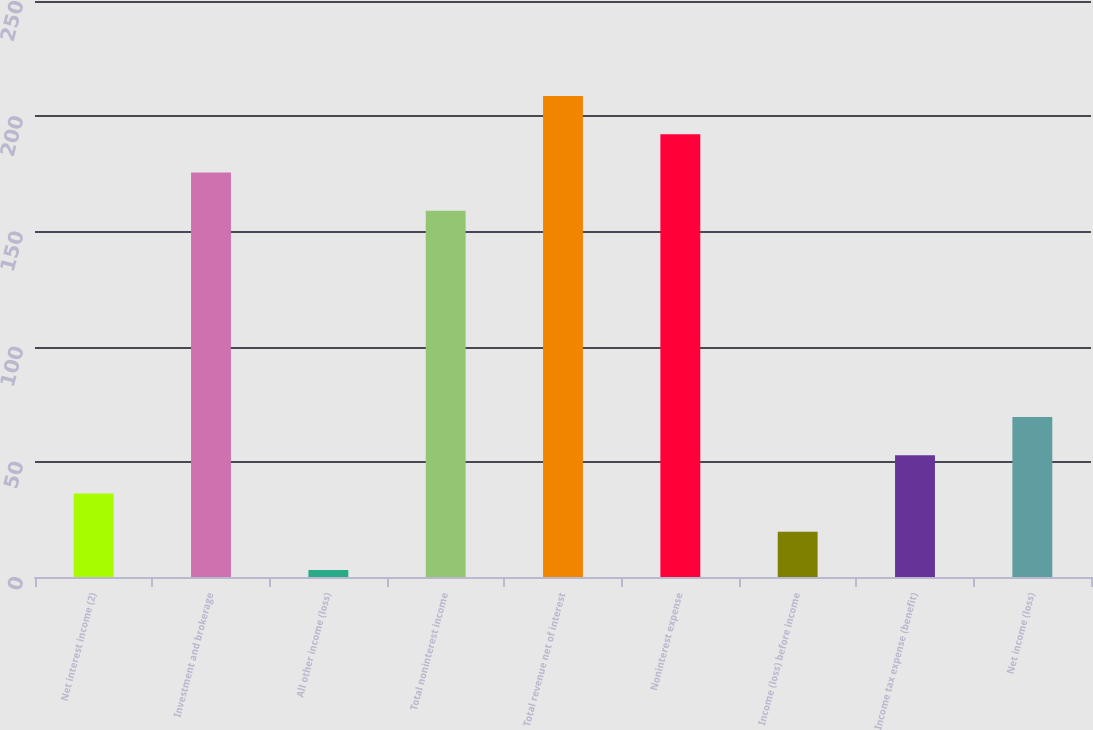<chart> <loc_0><loc_0><loc_500><loc_500><bar_chart><fcel>Net interest income (2)<fcel>Investment and brokerage<fcel>All other income (loss)<fcel>Total noninterest income<fcel>Total revenue net of interest<fcel>Noninterest expense<fcel>Income (loss) before income<fcel>Income tax expense (benefit)<fcel>Net income (loss)<nl><fcel>36.2<fcel>175.6<fcel>3<fcel>159<fcel>208.8<fcel>192.2<fcel>19.6<fcel>52.8<fcel>69.4<nl></chart> 